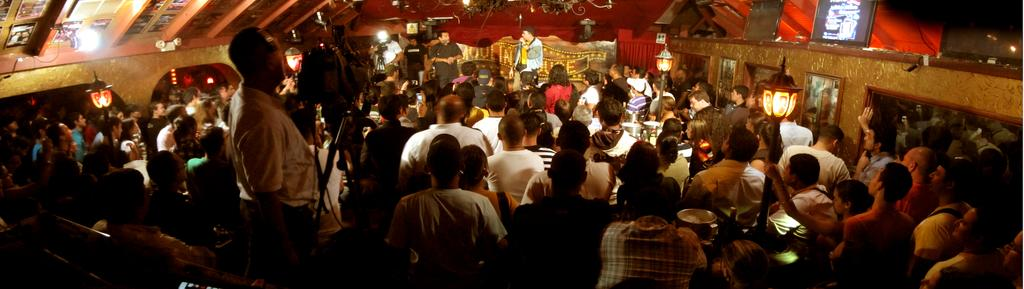What is the main subject of the image? The main subject of the image is a crowd. Are there any specific objects or structures visible in the image? Yes, there are light poles and a camera with a stand in the image. What else can be seen in the image? There are pictures visible in the image. What type of shirt is the plantation wearing in the image? There is no plantation or shirt present in the image. How many pizzas are being served to the crowd in the image? There is no mention of pizzas in the image; it only shows a crowd, light poles, a camera with a stand, and pictures. 